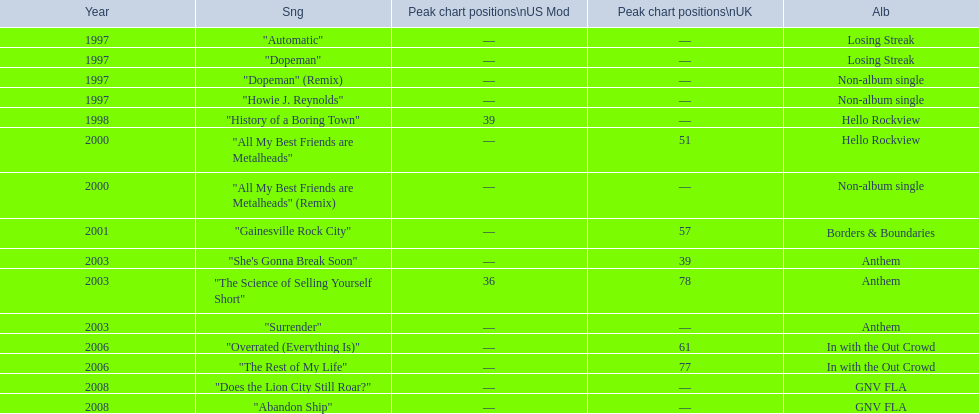Compare the chart positions between the us and the uk for the science of selling yourself short, where did it do better? US. 